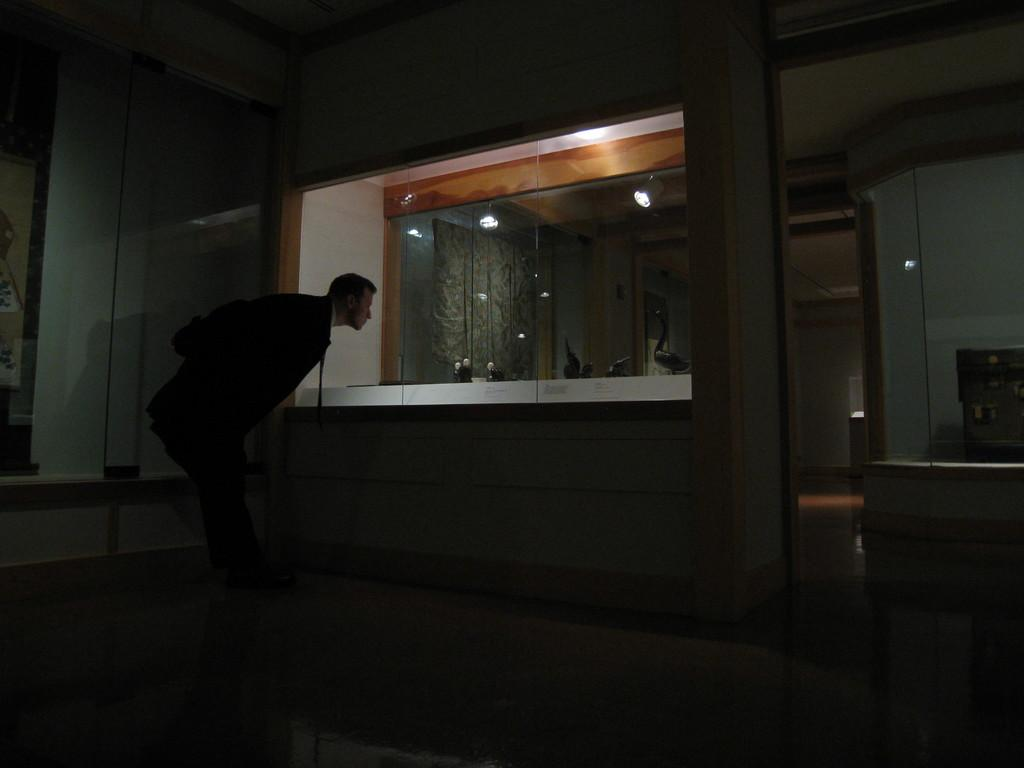What is the main subject of the image? There is a man standing in the image. Where is the man standing? The man is standing on the floor. What is the man doing in the image? The man is looking into a mirror. What can be seen in the background of the image? There are walls visible in the image. What type of lighting is present in the image? Electric lights are present in the image. What decorative elements can be seen in the image? Decor pieces and wall hangings are visible in the image. How does the wind affect the man's appearance in the image? There is no wind present in the image, so it does not affect the man's appearance. Is there a beggar visible in the image? No, there is no beggar present in the image; it features a man standing and looking into a mirror. 